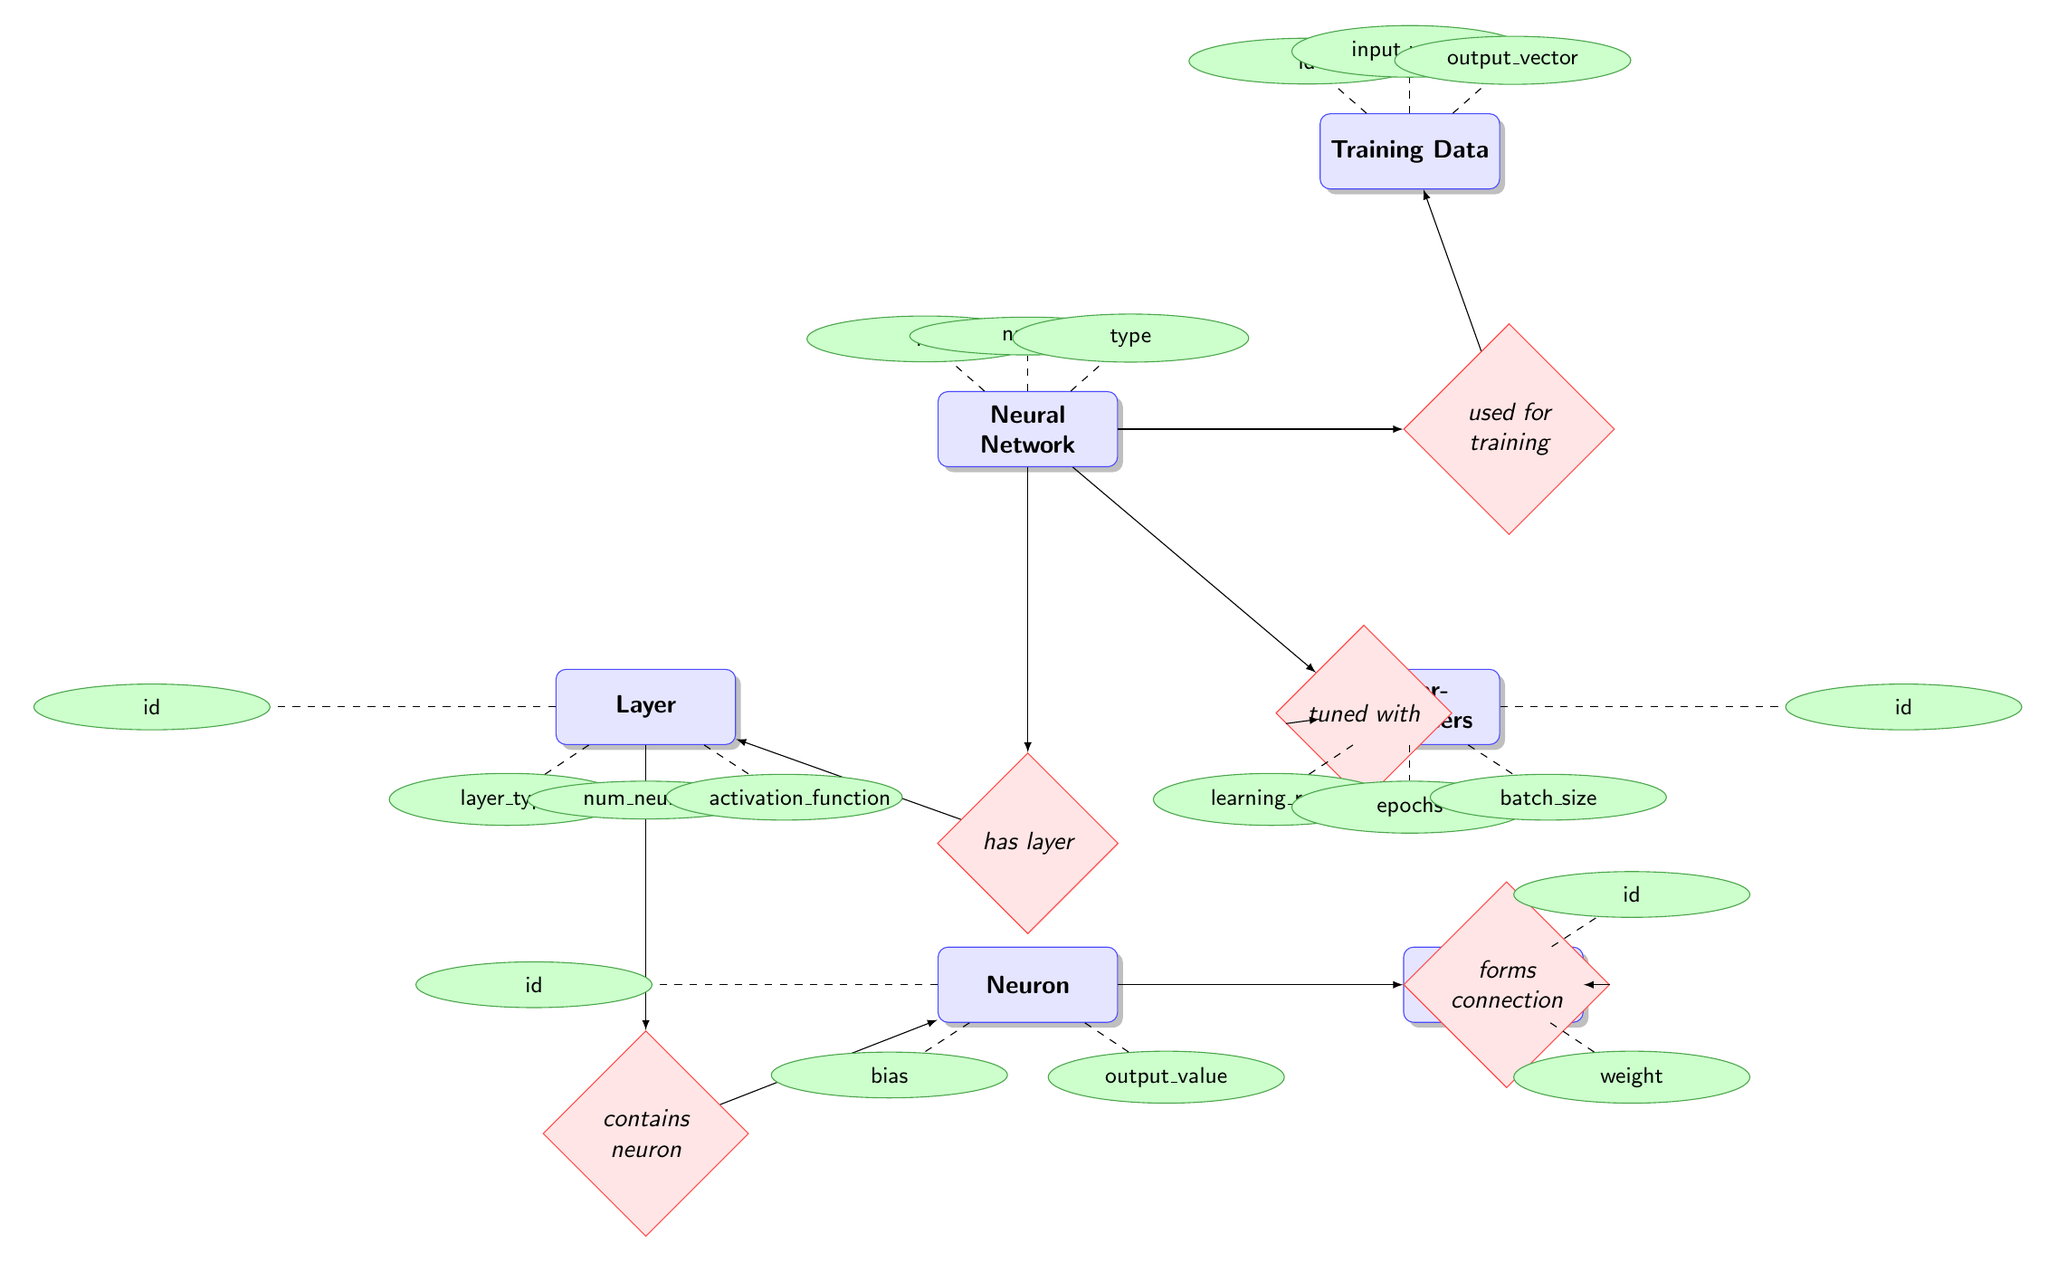What is the name of the relationship between Neural Network and Layer? The diagram shows that the relationship is labeled as "has layer," connecting the Neural Network entity to the Layer entity.
Answer: has layer How many attributes does the Layer entity have? The Layer entity has four attributes, which are id, layer_type, num_neurons, and activation_function.
Answer: four What is the output_value attribute of the Neuron entity? The Neuron entity has three attributes, including output_value, which represents a specific characteristic of the Neuron.
Answer: output_value Which entity contains the bias attribute? The Neuron entity contains the attribute bias, indicating a component of its structure.
Answer: Neuron What is the relationship that connects Neuron and Connection? The diagram indicates that the relationship is labeled "forms connection," which links the Neuron entity to the Connection entity.
Answer: forms connection What types of attributes does the NeuralNetwork entity have? The attributes of the NeuralNetwork entity are id, name, and type, which provide identifying information regarding the neural network's structure.
Answer: id, name, type Which entity is used for training the Neural Network? The TrainingData entity is indicated as the one used for training the Neural Network, establishing their connection.
Answer: TrainingData How many entities are related to the Neural Network? The diagram shows that the Neural Network is related to five entities: Layer, Training Data, Hyperparameters, Neuron, and Connection.
Answer: five What does the Hyperparameters entity tune? The Hyperparameters entity is used to tune the Neural Network, specifically affecting its training process by adjusting various settings.
Answer: Neural Network 